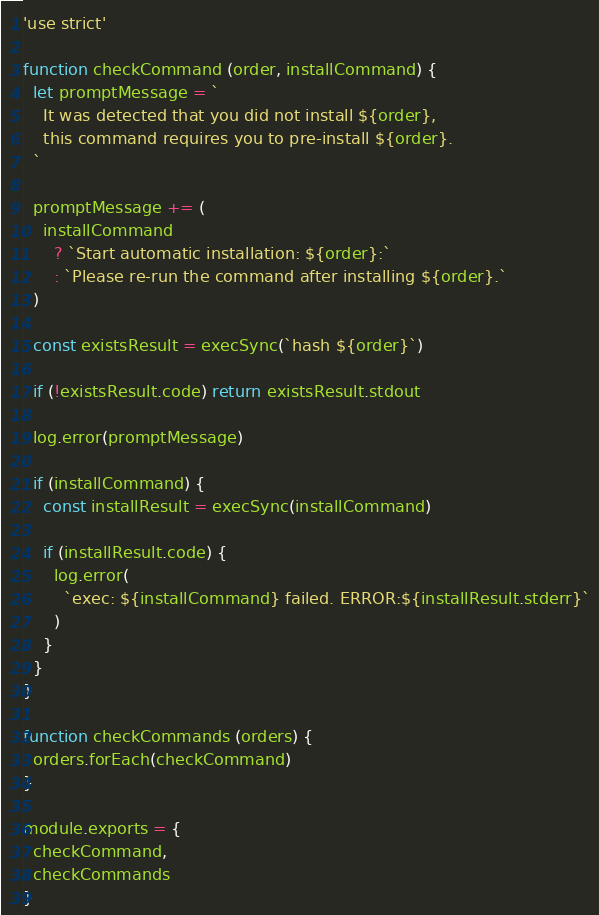Convert code to text. <code><loc_0><loc_0><loc_500><loc_500><_JavaScript_>'use strict'

function checkCommand (order, installCommand) {
  let promptMessage = `
    It was detected that you did not install ${order},
    this command requires you to pre-install ${order}.
  `

  promptMessage += (
    installCommand
      ? `Start automatic installation: ${order}:`
      : `Please re-run the command after installing ${order}.`
  )

  const existsResult = execSync(`hash ${order}`)

  if (!existsResult.code) return existsResult.stdout

  log.error(promptMessage)

  if (installCommand) {
    const installResult = execSync(installCommand)

    if (installResult.code) {
      log.error(
        `exec: ${installCommand} failed. ERROR:${installResult.stderr}`
      )
    }
  }
}

function checkCommands (orders) {
  orders.forEach(checkCommand)
}

module.exports = {
  checkCommand,
  checkCommands
}
</code> 